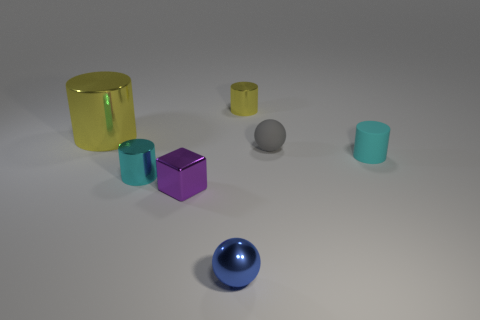Is there anything else that has the same shape as the purple object?
Your response must be concise. No. How big is the blue metal object that is in front of the small purple metallic cube left of the yellow metallic cylinder behind the large shiny object?
Your response must be concise. Small. Does the rubber thing behind the cyan rubber cylinder have the same size as the cyan rubber cylinder?
Give a very brief answer. Yes. How many other objects are the same material as the small purple cube?
Give a very brief answer. 4. Are there more gray spheres than blue metal blocks?
Provide a succinct answer. Yes. What material is the yellow object in front of the yellow object that is behind the yellow shiny cylinder that is in front of the small yellow object?
Provide a succinct answer. Metal. Does the small shiny ball have the same color as the rubber sphere?
Give a very brief answer. No. Are there any tiny matte cylinders of the same color as the shiny sphere?
Provide a short and direct response. No. The blue object that is the same size as the gray matte thing is what shape?
Keep it short and to the point. Sphere. Are there fewer gray spheres than brown metallic cubes?
Give a very brief answer. No. 